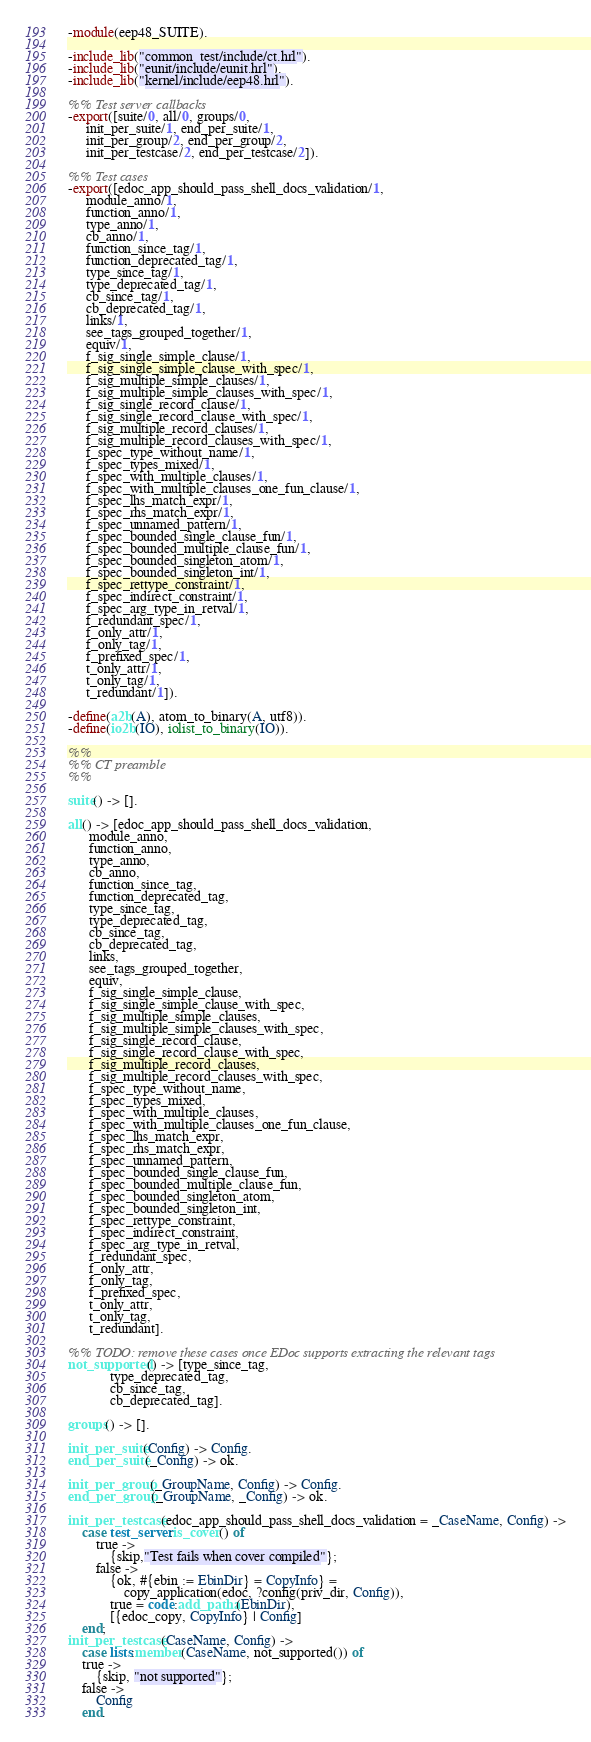<code> <loc_0><loc_0><loc_500><loc_500><_Erlang_>-module(eep48_SUITE).

-include_lib("common_test/include/ct.hrl").
-include_lib("eunit/include/eunit.hrl").
-include_lib("kernel/include/eep48.hrl").

%% Test server callbacks
-export([suite/0, all/0, groups/0,
	 init_per_suite/1, end_per_suite/1,
	 init_per_group/2, end_per_group/2,
	 init_per_testcase/2, end_per_testcase/2]).

%% Test cases
-export([edoc_app_should_pass_shell_docs_validation/1,
	 module_anno/1,
	 function_anno/1,
	 type_anno/1,
	 cb_anno/1,
	 function_since_tag/1,
	 function_deprecated_tag/1,
	 type_since_tag/1,
	 type_deprecated_tag/1,
	 cb_since_tag/1,
	 cb_deprecated_tag/1,
	 links/1,
	 see_tags_grouped_together/1,
	 equiv/1,
	 f_sig_single_simple_clause/1,
	 f_sig_single_simple_clause_with_spec/1,
	 f_sig_multiple_simple_clauses/1,
	 f_sig_multiple_simple_clauses_with_spec/1,
	 f_sig_single_record_clause/1,
	 f_sig_single_record_clause_with_spec/1,
	 f_sig_multiple_record_clauses/1,
	 f_sig_multiple_record_clauses_with_spec/1,
	 f_spec_type_without_name/1,
	 f_spec_types_mixed/1,
	 f_spec_with_multiple_clauses/1,
	 f_spec_with_multiple_clauses_one_fun_clause/1,
	 f_spec_lhs_match_expr/1,
	 f_spec_rhs_match_expr/1,
	 f_spec_unnamed_pattern/1,
	 f_spec_bounded_single_clause_fun/1,
	 f_spec_bounded_multiple_clause_fun/1,
	 f_spec_bounded_singleton_atom/1,
	 f_spec_bounded_singleton_int/1,
	 f_spec_rettype_constraint/1,
	 f_spec_indirect_constraint/1,
	 f_spec_arg_type_in_retval/1,
	 f_redundant_spec/1,
	 f_only_attr/1,
	 f_only_tag/1,
	 f_prefixed_spec/1,
	 t_only_attr/1,
	 t_only_tag/1,
	 t_redundant/1]).

-define(a2b(A), atom_to_binary(A, utf8)).
-define(io2b(IO), iolist_to_binary(IO)).

%%
%% CT preamble
%%

suite() -> [].

all() -> [edoc_app_should_pass_shell_docs_validation,
	  module_anno,
	  function_anno,
	  type_anno,
	  cb_anno,
	  function_since_tag,
	  function_deprecated_tag,
	  type_since_tag,
	  type_deprecated_tag,
	  cb_since_tag,
	  cb_deprecated_tag,
	  links,
	  see_tags_grouped_together,
	  equiv,
	  f_sig_single_simple_clause,
	  f_sig_single_simple_clause_with_spec,
	  f_sig_multiple_simple_clauses,
	  f_sig_multiple_simple_clauses_with_spec,
	  f_sig_single_record_clause,
	  f_sig_single_record_clause_with_spec,
	  f_sig_multiple_record_clauses,
	  f_sig_multiple_record_clauses_with_spec,
	  f_spec_type_without_name,
	  f_spec_types_mixed,
	  f_spec_with_multiple_clauses,
	  f_spec_with_multiple_clauses_one_fun_clause,
	  f_spec_lhs_match_expr,
	  f_spec_rhs_match_expr,
	  f_spec_unnamed_pattern,
	  f_spec_bounded_single_clause_fun,
	  f_spec_bounded_multiple_clause_fun,
	  f_spec_bounded_singleton_atom,
	  f_spec_bounded_singleton_int,
	  f_spec_rettype_constraint,
	  f_spec_indirect_constraint,
	  f_spec_arg_type_in_retval,
	  f_redundant_spec,
	  f_only_attr,
	  f_only_tag,
	  f_prefixed_spec,
	  t_only_attr,
	  t_only_tag,
	  t_redundant].

%% TODO: remove these cases once EDoc supports extracting the relevant tags
not_supported() -> [type_since_tag,
		    type_deprecated_tag,
		    cb_since_tag,
		    cb_deprecated_tag].

groups() -> [].

init_per_suite(Config) -> Config.
end_per_suite(_Config) -> ok.

init_per_group(_GroupName, Config) -> Config.
end_per_group(_GroupName, _Config) -> ok.

init_per_testcase(edoc_app_should_pass_shell_docs_validation = _CaseName, Config) ->
    case test_server:is_cover() of
        true ->
            {skip,"Test fails when cover compiled"};
        false ->
            {ok, #{ebin := EbinDir} = CopyInfo} =
                copy_application(edoc, ?config(priv_dir, Config)),
            true = code:add_patha(EbinDir),
            [{edoc_copy, CopyInfo} | Config]
    end;
init_per_testcase(CaseName, Config) ->
    case lists:member(CaseName, not_supported()) of
	true ->
	    {skip, "not supported"};
	false ->
	    Config
    end.
</code> 